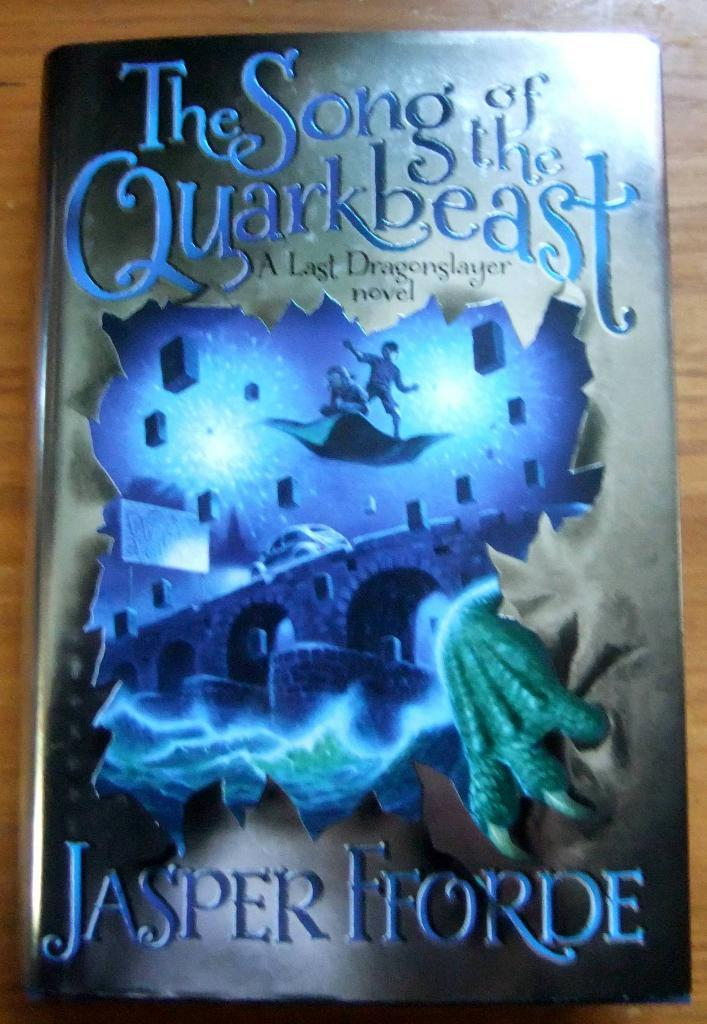Provide a one-sentence caption for the provided image. A book by the author Jasper Fforde has a blue cover. 